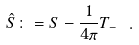Convert formula to latex. <formula><loc_0><loc_0><loc_500><loc_500>\hat { S } \colon = S - \frac { 1 } { 4 \pi } T _ { - } \ .</formula> 